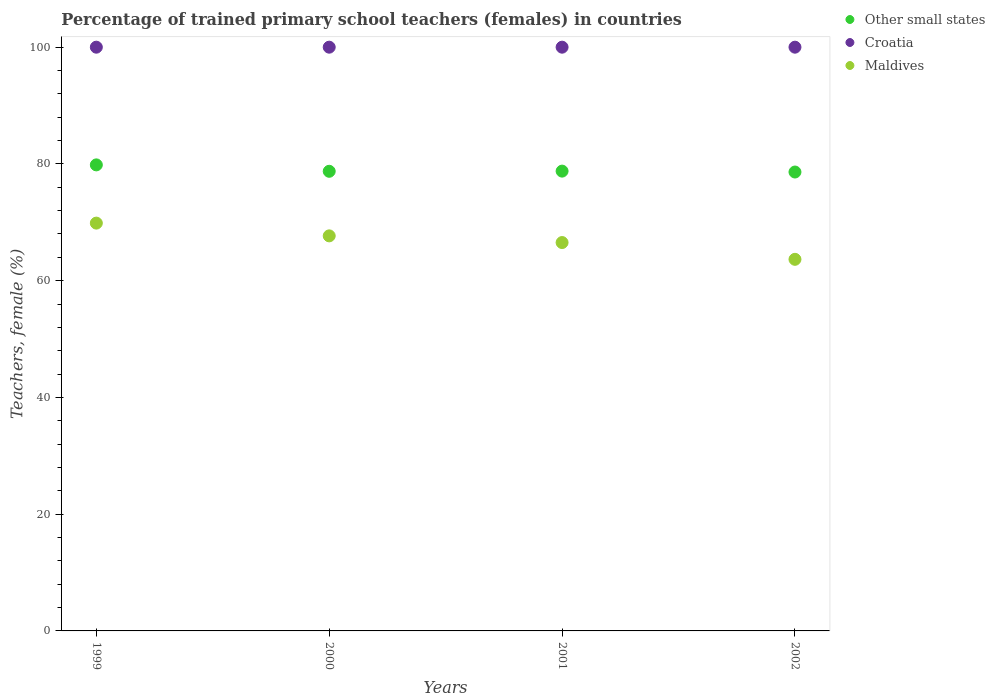Is the number of dotlines equal to the number of legend labels?
Give a very brief answer. Yes. What is the percentage of trained primary school teachers (females) in Other small states in 1999?
Your answer should be compact. 79.84. Across all years, what is the maximum percentage of trained primary school teachers (females) in Maldives?
Provide a short and direct response. 69.86. Across all years, what is the minimum percentage of trained primary school teachers (females) in Other small states?
Offer a terse response. 78.61. In which year was the percentage of trained primary school teachers (females) in Croatia minimum?
Your answer should be compact. 1999. What is the difference between the percentage of trained primary school teachers (females) in Croatia in 1999 and that in 2000?
Give a very brief answer. 0. What is the difference between the percentage of trained primary school teachers (females) in Croatia in 1999 and the percentage of trained primary school teachers (females) in Maldives in 2001?
Give a very brief answer. 33.47. In the year 2001, what is the difference between the percentage of trained primary school teachers (females) in Croatia and percentage of trained primary school teachers (females) in Maldives?
Your answer should be very brief. 33.47. In how many years, is the percentage of trained primary school teachers (females) in Other small states greater than 8 %?
Your answer should be very brief. 4. What is the ratio of the percentage of trained primary school teachers (females) in Other small states in 1999 to that in 2000?
Offer a terse response. 1.01. Is the percentage of trained primary school teachers (females) in Croatia in 2000 less than that in 2001?
Keep it short and to the point. No. Is the difference between the percentage of trained primary school teachers (females) in Croatia in 2000 and 2001 greater than the difference between the percentage of trained primary school teachers (females) in Maldives in 2000 and 2001?
Make the answer very short. No. What is the difference between the highest and the second highest percentage of trained primary school teachers (females) in Other small states?
Ensure brevity in your answer.  1.07. What is the difference between the highest and the lowest percentage of trained primary school teachers (females) in Maldives?
Make the answer very short. 6.2. Is it the case that in every year, the sum of the percentage of trained primary school teachers (females) in Maldives and percentage of trained primary school teachers (females) in Croatia  is greater than the percentage of trained primary school teachers (females) in Other small states?
Your answer should be very brief. Yes. Is the percentage of trained primary school teachers (females) in Other small states strictly greater than the percentage of trained primary school teachers (females) in Croatia over the years?
Ensure brevity in your answer.  No. How many dotlines are there?
Your answer should be very brief. 3. What is the difference between two consecutive major ticks on the Y-axis?
Offer a terse response. 20. Are the values on the major ticks of Y-axis written in scientific E-notation?
Provide a succinct answer. No. Does the graph contain any zero values?
Give a very brief answer. No. Does the graph contain grids?
Make the answer very short. No. How many legend labels are there?
Offer a terse response. 3. What is the title of the graph?
Keep it short and to the point. Percentage of trained primary school teachers (females) in countries. What is the label or title of the X-axis?
Your answer should be compact. Years. What is the label or title of the Y-axis?
Provide a succinct answer. Teachers, female (%). What is the Teachers, female (%) of Other small states in 1999?
Ensure brevity in your answer.  79.84. What is the Teachers, female (%) of Croatia in 1999?
Give a very brief answer. 100. What is the Teachers, female (%) of Maldives in 1999?
Offer a very short reply. 69.86. What is the Teachers, female (%) in Other small states in 2000?
Provide a succinct answer. 78.74. What is the Teachers, female (%) in Croatia in 2000?
Your response must be concise. 100. What is the Teachers, female (%) in Maldives in 2000?
Provide a short and direct response. 67.68. What is the Teachers, female (%) of Other small states in 2001?
Offer a terse response. 78.77. What is the Teachers, female (%) in Croatia in 2001?
Offer a very short reply. 100. What is the Teachers, female (%) in Maldives in 2001?
Give a very brief answer. 66.53. What is the Teachers, female (%) in Other small states in 2002?
Ensure brevity in your answer.  78.61. What is the Teachers, female (%) of Croatia in 2002?
Make the answer very short. 100. What is the Teachers, female (%) in Maldives in 2002?
Make the answer very short. 63.66. Across all years, what is the maximum Teachers, female (%) in Other small states?
Ensure brevity in your answer.  79.84. Across all years, what is the maximum Teachers, female (%) of Croatia?
Offer a terse response. 100. Across all years, what is the maximum Teachers, female (%) of Maldives?
Offer a very short reply. 69.86. Across all years, what is the minimum Teachers, female (%) of Other small states?
Ensure brevity in your answer.  78.61. Across all years, what is the minimum Teachers, female (%) in Maldives?
Your response must be concise. 63.66. What is the total Teachers, female (%) of Other small states in the graph?
Offer a very short reply. 315.96. What is the total Teachers, female (%) in Maldives in the graph?
Your answer should be compact. 267.73. What is the difference between the Teachers, female (%) of Other small states in 1999 and that in 2000?
Provide a short and direct response. 1.1. What is the difference between the Teachers, female (%) in Maldives in 1999 and that in 2000?
Provide a succinct answer. 2.19. What is the difference between the Teachers, female (%) in Other small states in 1999 and that in 2001?
Provide a short and direct response. 1.07. What is the difference between the Teachers, female (%) in Croatia in 1999 and that in 2001?
Provide a short and direct response. 0. What is the difference between the Teachers, female (%) of Maldives in 1999 and that in 2001?
Give a very brief answer. 3.33. What is the difference between the Teachers, female (%) of Other small states in 1999 and that in 2002?
Ensure brevity in your answer.  1.22. What is the difference between the Teachers, female (%) in Maldives in 1999 and that in 2002?
Your answer should be compact. 6.2. What is the difference between the Teachers, female (%) of Other small states in 2000 and that in 2001?
Make the answer very short. -0.03. What is the difference between the Teachers, female (%) of Maldives in 2000 and that in 2001?
Keep it short and to the point. 1.14. What is the difference between the Teachers, female (%) in Other small states in 2000 and that in 2002?
Offer a terse response. 0.13. What is the difference between the Teachers, female (%) in Maldives in 2000 and that in 2002?
Provide a short and direct response. 4.02. What is the difference between the Teachers, female (%) of Other small states in 2001 and that in 2002?
Make the answer very short. 0.16. What is the difference between the Teachers, female (%) of Maldives in 2001 and that in 2002?
Your response must be concise. 2.87. What is the difference between the Teachers, female (%) of Other small states in 1999 and the Teachers, female (%) of Croatia in 2000?
Provide a short and direct response. -20.16. What is the difference between the Teachers, female (%) of Other small states in 1999 and the Teachers, female (%) of Maldives in 2000?
Ensure brevity in your answer.  12.16. What is the difference between the Teachers, female (%) in Croatia in 1999 and the Teachers, female (%) in Maldives in 2000?
Give a very brief answer. 32.32. What is the difference between the Teachers, female (%) of Other small states in 1999 and the Teachers, female (%) of Croatia in 2001?
Your response must be concise. -20.16. What is the difference between the Teachers, female (%) in Other small states in 1999 and the Teachers, female (%) in Maldives in 2001?
Offer a terse response. 13.31. What is the difference between the Teachers, female (%) of Croatia in 1999 and the Teachers, female (%) of Maldives in 2001?
Offer a terse response. 33.47. What is the difference between the Teachers, female (%) of Other small states in 1999 and the Teachers, female (%) of Croatia in 2002?
Make the answer very short. -20.16. What is the difference between the Teachers, female (%) in Other small states in 1999 and the Teachers, female (%) in Maldives in 2002?
Your answer should be very brief. 16.18. What is the difference between the Teachers, female (%) in Croatia in 1999 and the Teachers, female (%) in Maldives in 2002?
Provide a short and direct response. 36.34. What is the difference between the Teachers, female (%) of Other small states in 2000 and the Teachers, female (%) of Croatia in 2001?
Give a very brief answer. -21.26. What is the difference between the Teachers, female (%) of Other small states in 2000 and the Teachers, female (%) of Maldives in 2001?
Your response must be concise. 12.21. What is the difference between the Teachers, female (%) of Croatia in 2000 and the Teachers, female (%) of Maldives in 2001?
Keep it short and to the point. 33.47. What is the difference between the Teachers, female (%) of Other small states in 2000 and the Teachers, female (%) of Croatia in 2002?
Give a very brief answer. -21.26. What is the difference between the Teachers, female (%) of Other small states in 2000 and the Teachers, female (%) of Maldives in 2002?
Your response must be concise. 15.08. What is the difference between the Teachers, female (%) of Croatia in 2000 and the Teachers, female (%) of Maldives in 2002?
Keep it short and to the point. 36.34. What is the difference between the Teachers, female (%) in Other small states in 2001 and the Teachers, female (%) in Croatia in 2002?
Your response must be concise. -21.23. What is the difference between the Teachers, female (%) in Other small states in 2001 and the Teachers, female (%) in Maldives in 2002?
Your answer should be compact. 15.11. What is the difference between the Teachers, female (%) in Croatia in 2001 and the Teachers, female (%) in Maldives in 2002?
Offer a very short reply. 36.34. What is the average Teachers, female (%) of Other small states per year?
Give a very brief answer. 78.99. What is the average Teachers, female (%) of Croatia per year?
Keep it short and to the point. 100. What is the average Teachers, female (%) of Maldives per year?
Give a very brief answer. 66.93. In the year 1999, what is the difference between the Teachers, female (%) of Other small states and Teachers, female (%) of Croatia?
Your answer should be very brief. -20.16. In the year 1999, what is the difference between the Teachers, female (%) of Other small states and Teachers, female (%) of Maldives?
Offer a very short reply. 9.98. In the year 1999, what is the difference between the Teachers, female (%) in Croatia and Teachers, female (%) in Maldives?
Provide a short and direct response. 30.14. In the year 2000, what is the difference between the Teachers, female (%) of Other small states and Teachers, female (%) of Croatia?
Provide a short and direct response. -21.26. In the year 2000, what is the difference between the Teachers, female (%) in Other small states and Teachers, female (%) in Maldives?
Your answer should be very brief. 11.06. In the year 2000, what is the difference between the Teachers, female (%) in Croatia and Teachers, female (%) in Maldives?
Make the answer very short. 32.32. In the year 2001, what is the difference between the Teachers, female (%) of Other small states and Teachers, female (%) of Croatia?
Offer a very short reply. -21.23. In the year 2001, what is the difference between the Teachers, female (%) in Other small states and Teachers, female (%) in Maldives?
Offer a terse response. 12.24. In the year 2001, what is the difference between the Teachers, female (%) in Croatia and Teachers, female (%) in Maldives?
Your answer should be very brief. 33.47. In the year 2002, what is the difference between the Teachers, female (%) in Other small states and Teachers, female (%) in Croatia?
Keep it short and to the point. -21.39. In the year 2002, what is the difference between the Teachers, female (%) of Other small states and Teachers, female (%) of Maldives?
Provide a short and direct response. 14.96. In the year 2002, what is the difference between the Teachers, female (%) of Croatia and Teachers, female (%) of Maldives?
Provide a succinct answer. 36.34. What is the ratio of the Teachers, female (%) in Croatia in 1999 to that in 2000?
Provide a short and direct response. 1. What is the ratio of the Teachers, female (%) of Maldives in 1999 to that in 2000?
Provide a succinct answer. 1.03. What is the ratio of the Teachers, female (%) in Other small states in 1999 to that in 2001?
Provide a succinct answer. 1.01. What is the ratio of the Teachers, female (%) in Croatia in 1999 to that in 2001?
Provide a short and direct response. 1. What is the ratio of the Teachers, female (%) of Maldives in 1999 to that in 2001?
Give a very brief answer. 1.05. What is the ratio of the Teachers, female (%) in Other small states in 1999 to that in 2002?
Your answer should be very brief. 1.02. What is the ratio of the Teachers, female (%) in Maldives in 1999 to that in 2002?
Offer a terse response. 1.1. What is the ratio of the Teachers, female (%) of Other small states in 2000 to that in 2001?
Your answer should be very brief. 1. What is the ratio of the Teachers, female (%) of Maldives in 2000 to that in 2001?
Provide a short and direct response. 1.02. What is the ratio of the Teachers, female (%) in Maldives in 2000 to that in 2002?
Provide a short and direct response. 1.06. What is the ratio of the Teachers, female (%) of Croatia in 2001 to that in 2002?
Your response must be concise. 1. What is the ratio of the Teachers, female (%) of Maldives in 2001 to that in 2002?
Ensure brevity in your answer.  1.05. What is the difference between the highest and the second highest Teachers, female (%) of Other small states?
Make the answer very short. 1.07. What is the difference between the highest and the second highest Teachers, female (%) of Croatia?
Your answer should be very brief. 0. What is the difference between the highest and the second highest Teachers, female (%) in Maldives?
Your response must be concise. 2.19. What is the difference between the highest and the lowest Teachers, female (%) of Other small states?
Keep it short and to the point. 1.22. What is the difference between the highest and the lowest Teachers, female (%) of Croatia?
Keep it short and to the point. 0. What is the difference between the highest and the lowest Teachers, female (%) of Maldives?
Provide a succinct answer. 6.2. 